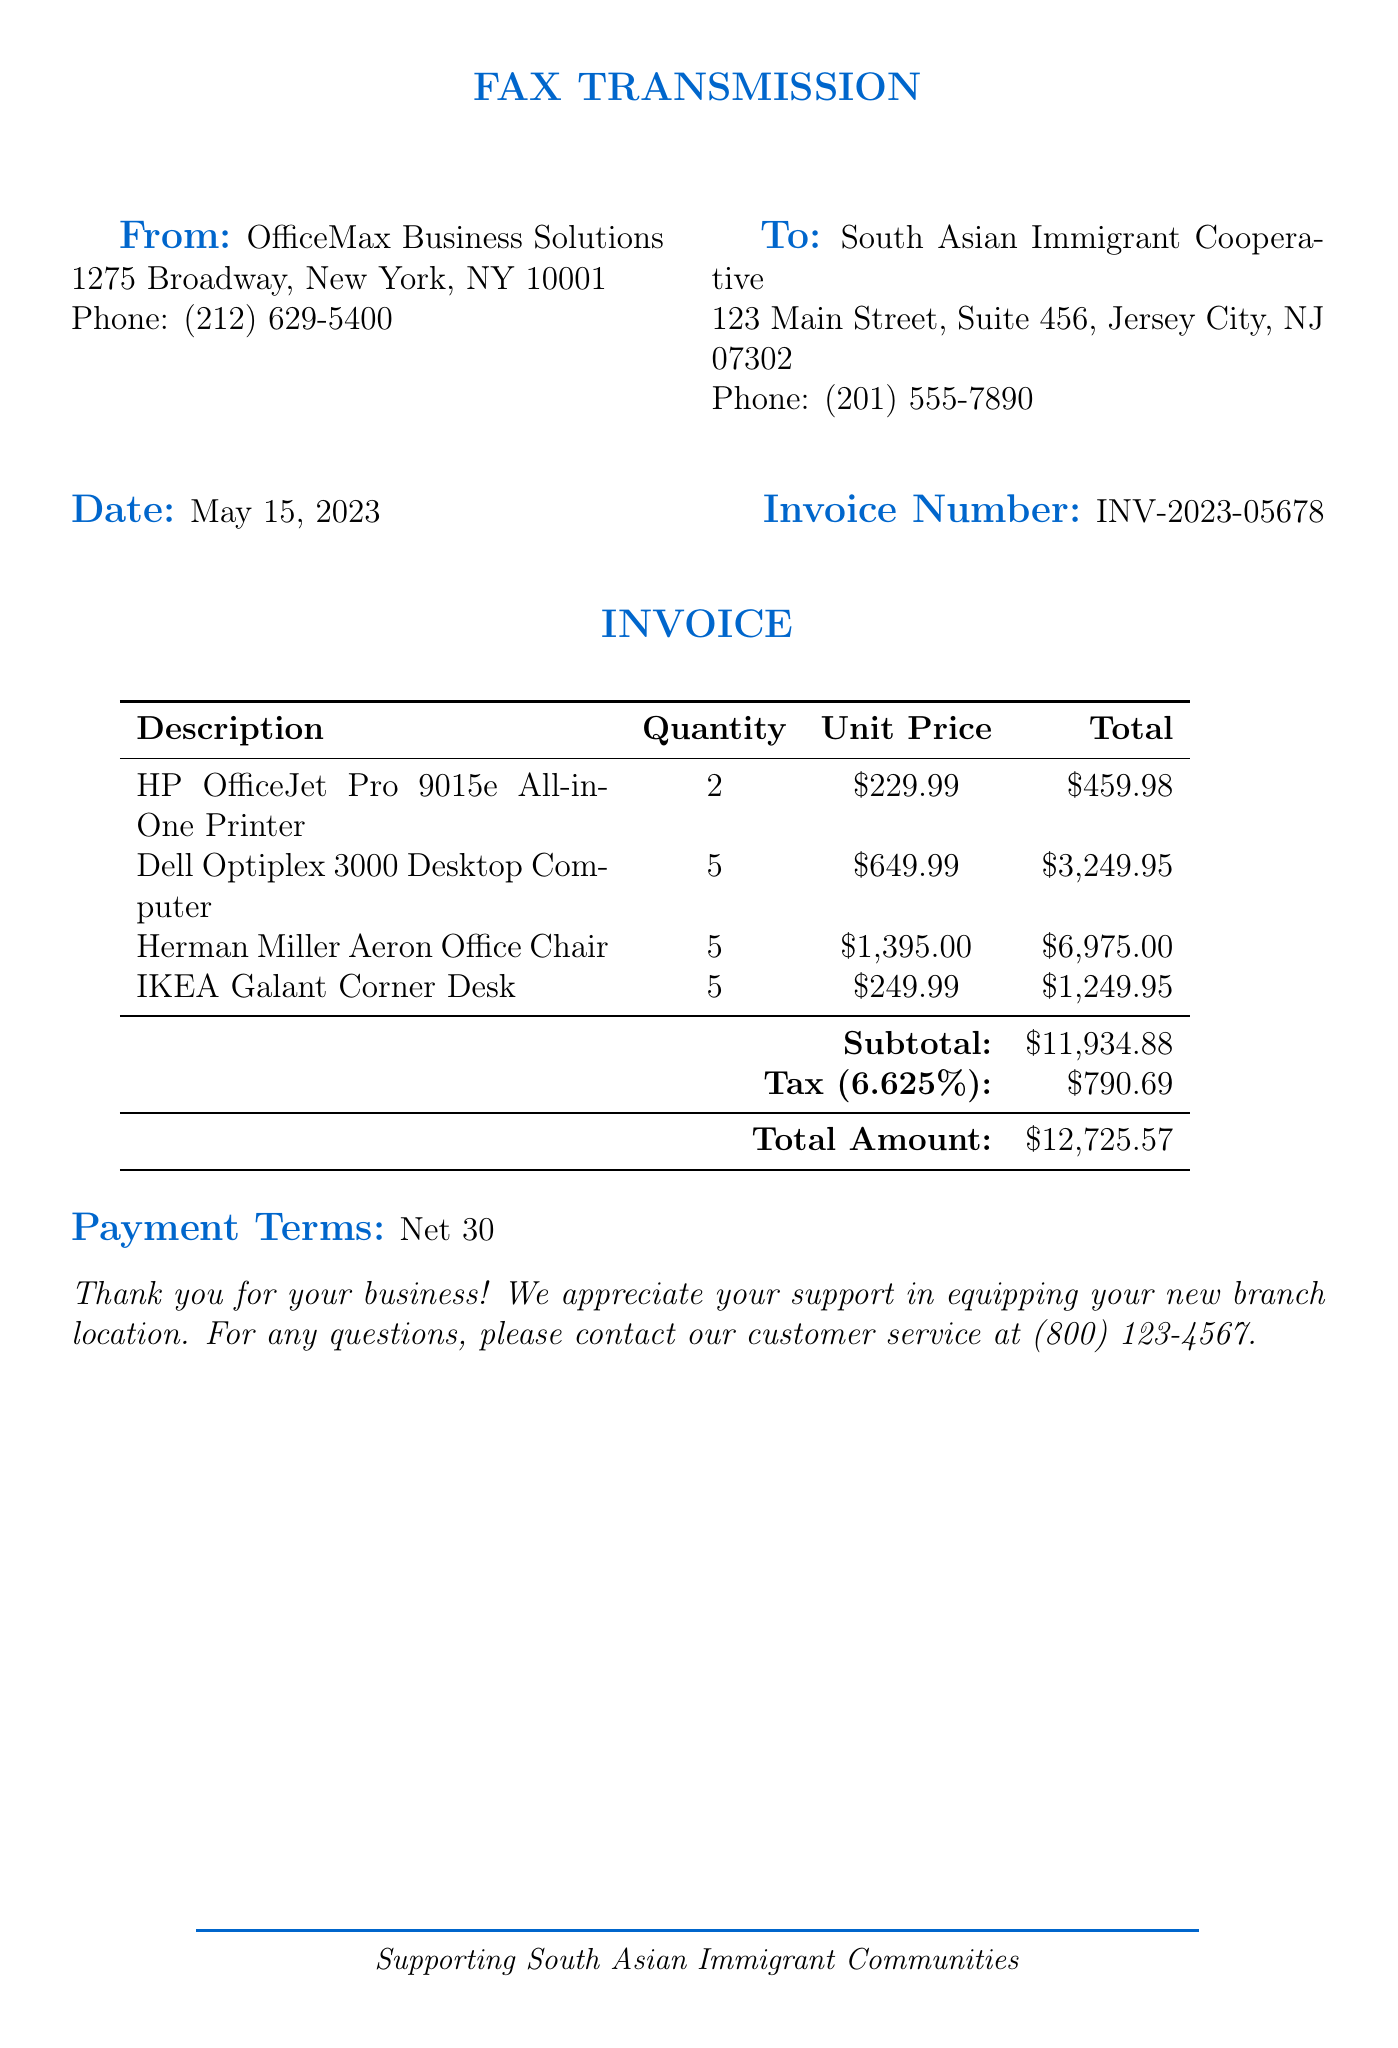What is the invoice number? The invoice number is clearly stated in the document, which helps to track the transaction.
Answer: INV-2023-05678 What is the date of the fax? The date indicates when the invoice was sent, providing a timeline for payment processing.
Answer: May 15, 2023 How many Dell Optiplex 3000 Desktop Computers were purchased? The quantity provides insight into the number of units needed for the new branch location.
Answer: 5 What is the subtotal of the invoice? The subtotal reflects the total cost of items before tax, important for accounting purposes.
Answer: $11,934.88 What are the payment terms listed in the fax? Payment terms are crucial for financial planning and managing cash flow in the cooperative.
Answer: Net 30 What is the total amount due for the invoice? The total amount informs the cooperative of the final cost that needs to be paid.
Answer: $12,725.57 What is the tax rate applied to the invoice? The tax rate helps in understanding the additional costs to consider when budgeting.
Answer: 6.625% What is the contact number for customer service? Knowing the customer service contact number allows for follow-up questions or issues with the invoice.
Answer: (800) 123-4567 